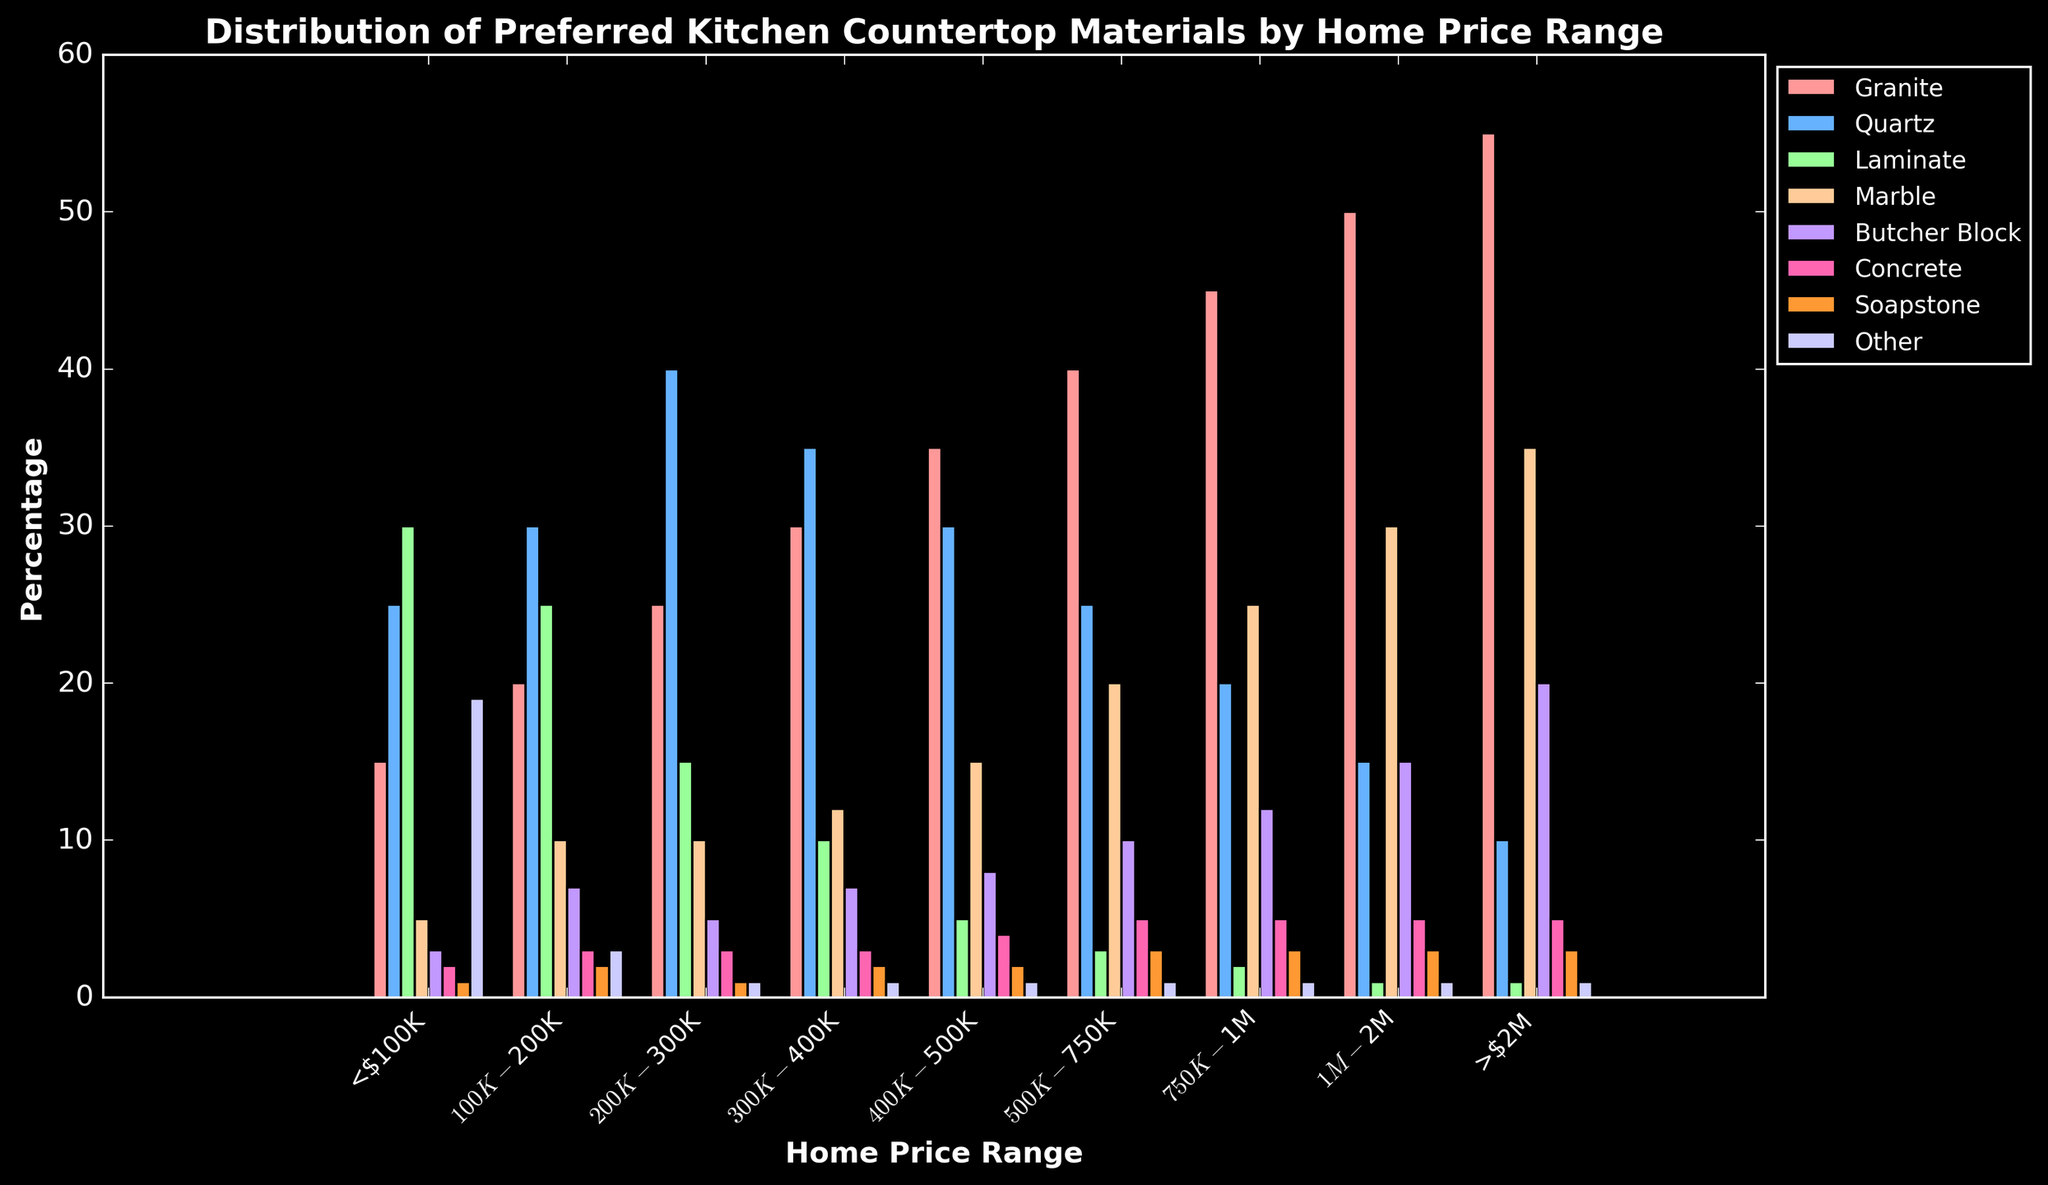What's the most preferred kitchen countertop material for homes priced under $100K? By observing the bar chart, we see that Laminate has the highest percentage for homes under $100K with a value of 30.
Answer: Laminate How does the preference for Granite change as home prices increase? As home prices increase, the preference for Granite also increases. From homes priced under $100K to homes priced over $2M, the percentage increases from 15 to 55.
Answer: Increases Which home price range has the highest percentage preference for Marble countertops? By inspecting the chart, we see that homes priced over $2M have the highest preference for Marble at 35%.
Answer: >$2M Compare the preference for Quartz and Concrete in the $300K-$400K range. Which is higher and by how much? In the $300K-$400K price range, Quartz has a preference of 35%, while Concrete has a preference of 3%. Therefore, Quartz is higher by 32%.
Answer: Quartz by 32% What's the total percentage of homes priced between $200K and $300K that prefer either Granite or Laminate countertops? For homes priced between $200K and $300K: Granite preference is 25%, and Laminate preference is 15%. So, the total is 25 + 15 = 40%.
Answer: 40% In which home price range is the preference for Butcher Block the lowest? We observe that the preference for Butcher Block is the lowest in the <$100K range, with a percentage of 3%.
Answer: <$100K What is the primary countertop material for homes priced between $1M and $2M? For homes priced between $1M and $2M, Granite is the primary material with the highest preference at 50%.
Answer: Granite Calculate the difference in preference for Soapstone countertops between the $100K-$200K and $500K-$750K home price ranges. For the $100K-$200K range, Soapstone preference is 2%. For the $500K-$750K range, it is 3%. The difference is 3 - 2 = 1%.
Answer: 1% Which countertop material sees the most significant preference increase as home prices move from $100K-$200K to >$2M? Examining the chart, Granite preference increases from 20% in the $100K-$200K range to 55% in the >$2M range, which is a significant increase of 35%.
Answer: Granite Compare the preference for Marble and Other materials in homes priced under $100K. Which one is more preferred and by what percentage? In homes priced under $100K: Marble has a preference of 5%, while Other materials have a preference of 19%. Thus, Other materials are preferred by 14% more than Marble.
Answer: Other by 14% 